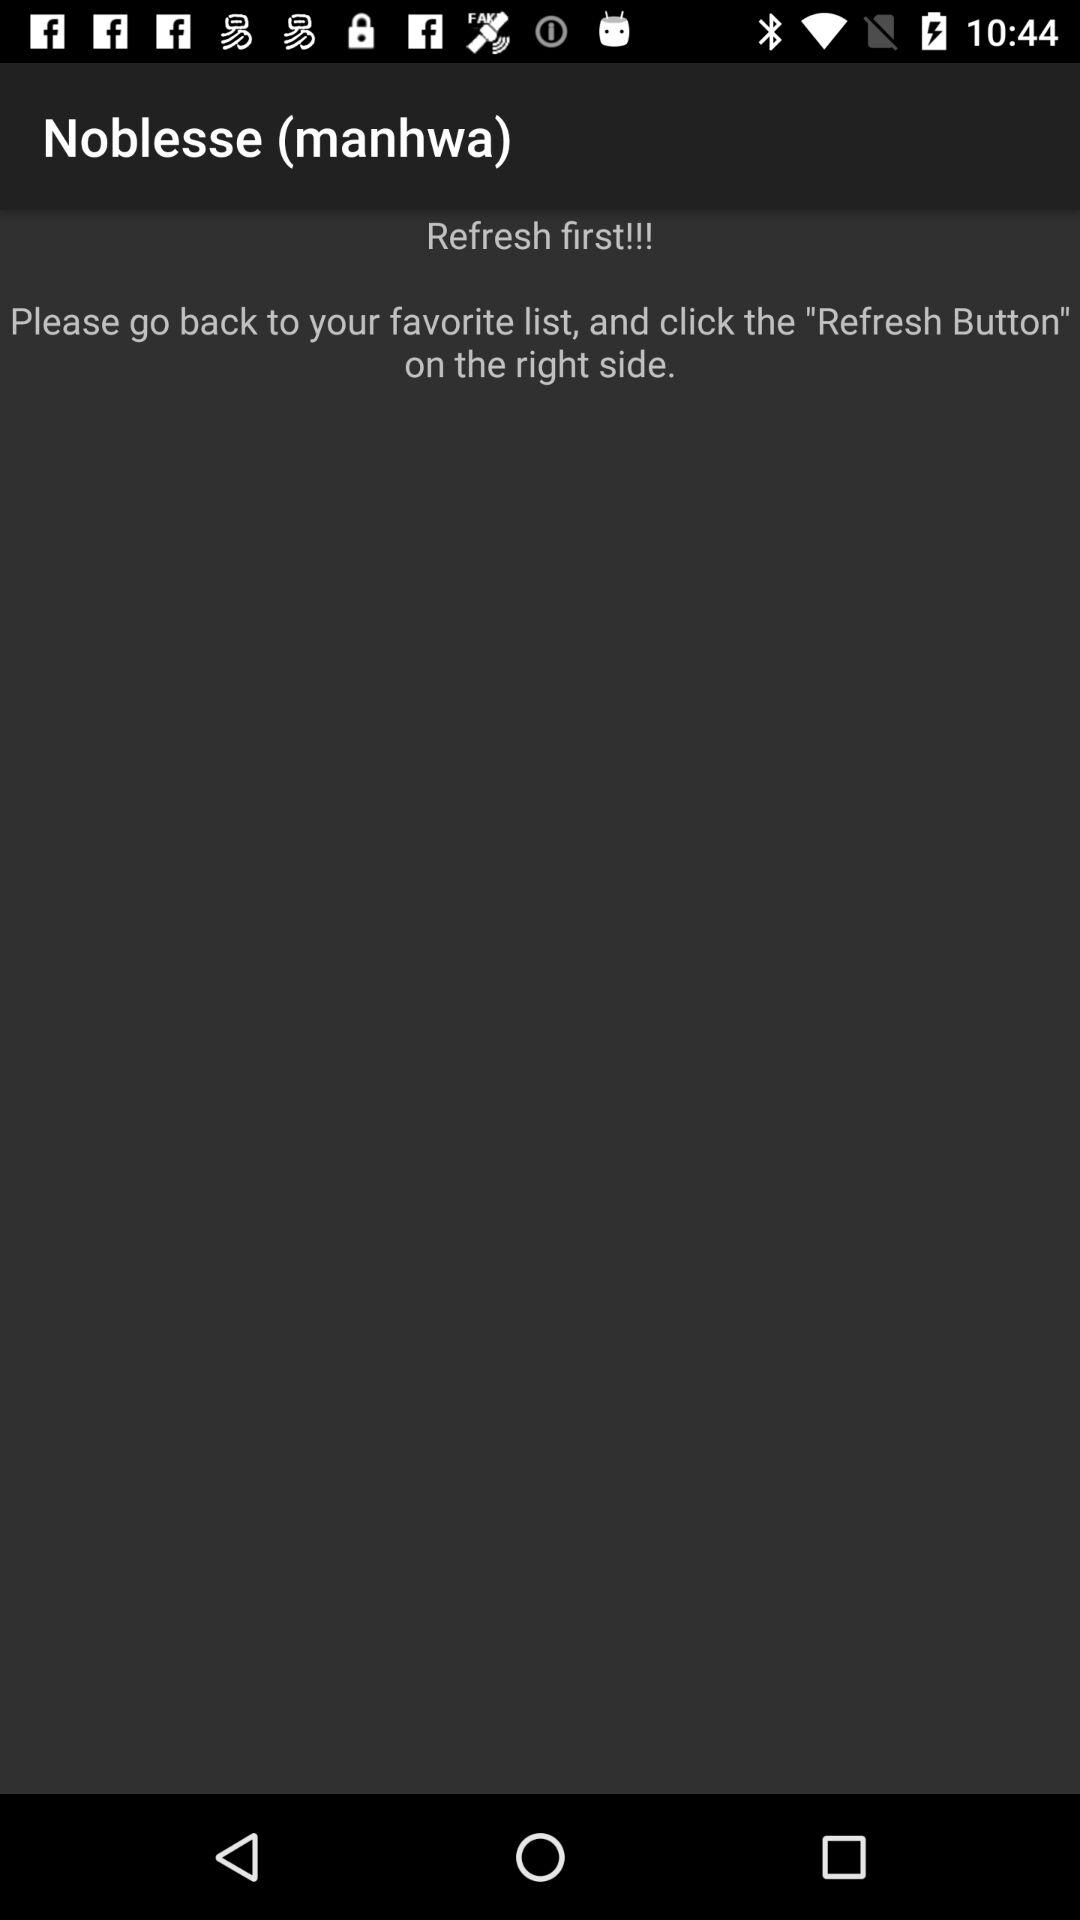What is the application name?
When the provided information is insufficient, respond with <no answer>. <no answer> 